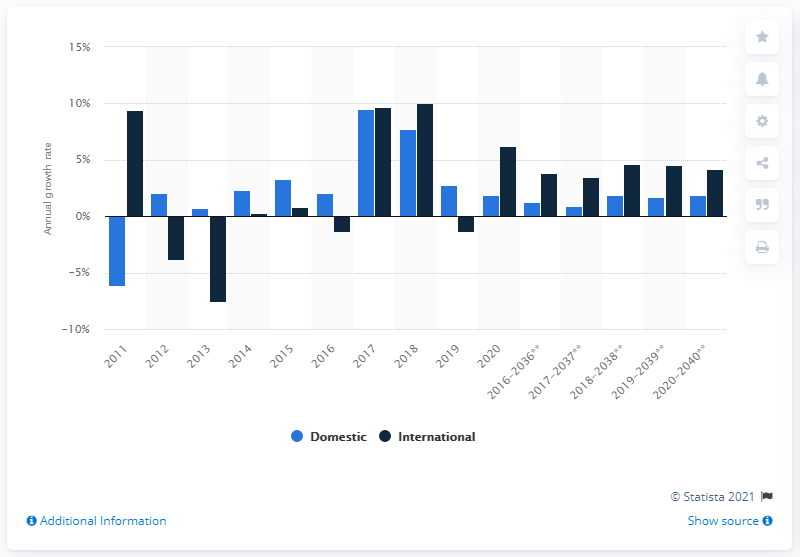Give some essential details in this illustration. The projected compound annual growth rate of domestic remanufactured truck market in North America between 2020 and 2040 is expected to be 1.9%. 